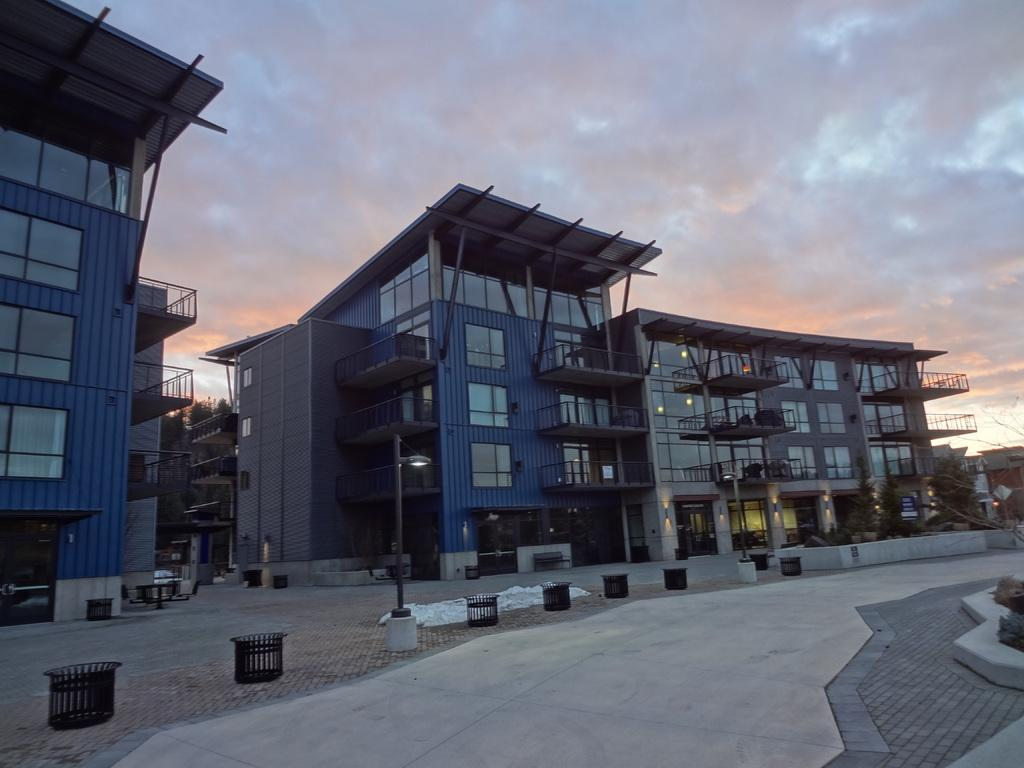What is the weather like in the image? The sky is cloudy in the image. What type of structures can be seen in the image? There are buildings in the image. What is in front of the buildings? Light poles, bins, and trees are present in front of the buildings. What type of windows do the buildings have? The buildings have glass windows. What substance is the tree biting in the image? There is no tree biting anything in the image; trees do not have the ability to bite. 